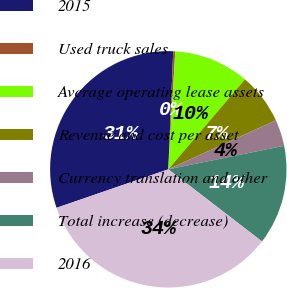Convert chart. <chart><loc_0><loc_0><loc_500><loc_500><pie_chart><fcel>2015<fcel>Used truck sales<fcel>Average operating lease assets<fcel>Revenue and cost per asset<fcel>Currency translation and other<fcel>Total increase (decrease)<fcel>2016<nl><fcel>30.94%<fcel>0.28%<fcel>10.29%<fcel>6.96%<fcel>3.62%<fcel>13.63%<fcel>34.28%<nl></chart> 